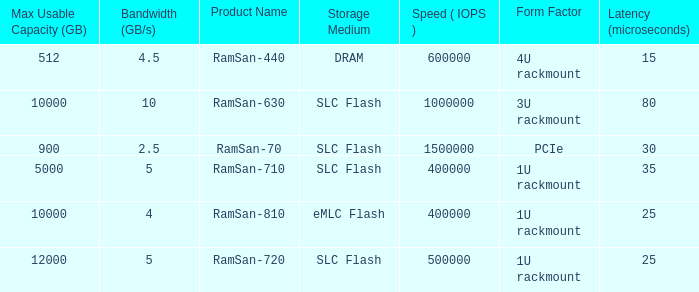List the number of ramsan-720 hard drives? 1.0. Can you parse all the data within this table? {'header': ['Max Usable Capacity (GB)', 'Bandwidth (GB/s)', 'Product Name', 'Storage Medium', 'Speed ( IOPS )', 'Form Factor', 'Latency (microseconds)'], 'rows': [['512', '4.5', 'RamSan-440', 'DRAM', '600000', '4U rackmount', '15'], ['10000', '10', 'RamSan-630', 'SLC Flash', '1000000', '3U rackmount', '80'], ['900', '2.5', 'RamSan-70', 'SLC Flash', '1500000', 'PCIe', '30'], ['5000', '5', 'RamSan-710', 'SLC Flash', '400000', '1U rackmount', '35'], ['10000', '4', 'RamSan-810', 'eMLC Flash', '400000', '1U rackmount', '25'], ['12000', '5', 'RamSan-720', 'SLC Flash', '500000', '1U rackmount', '25']]} 